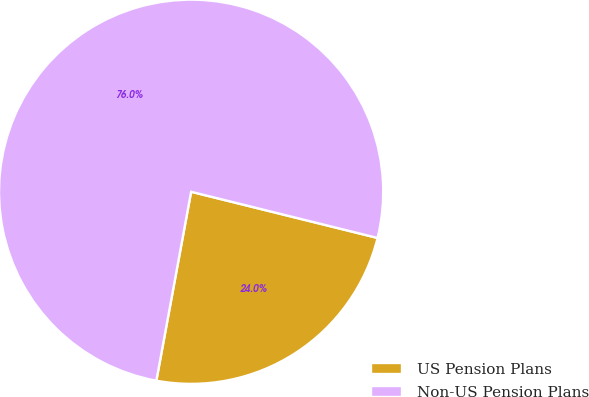<chart> <loc_0><loc_0><loc_500><loc_500><pie_chart><fcel>US Pension Plans<fcel>Non-US Pension Plans<nl><fcel>24.03%<fcel>75.97%<nl></chart> 